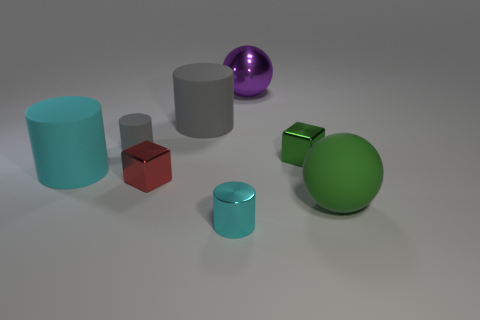The rubber thing that is the same color as the small metal cylinder is what size?
Your response must be concise. Large. There is a tiny cube that is the same color as the rubber sphere; what is it made of?
Your response must be concise. Metal. Do the ball that is behind the small green block and the tiny cyan object have the same material?
Offer a terse response. Yes. Are there an equal number of small green shiny objects on the left side of the big purple object and big spheres that are in front of the small gray matte thing?
Offer a terse response. No. Is there anything else that is the same size as the red object?
Your answer should be very brief. Yes. There is another cyan thing that is the same shape as the cyan rubber thing; what is its material?
Provide a succinct answer. Metal. Are there any cylinders in front of the small cube that is on the left side of the small metal object that is to the right of the big purple shiny object?
Your response must be concise. Yes. There is a big thing behind the big gray cylinder; does it have the same shape as the gray rubber thing that is in front of the big gray thing?
Your response must be concise. No. Is the number of tiny cyan shiny objects behind the small green metallic object greater than the number of large cyan rubber objects?
Give a very brief answer. No. How many things are yellow shiny blocks or gray objects?
Provide a succinct answer. 2. 